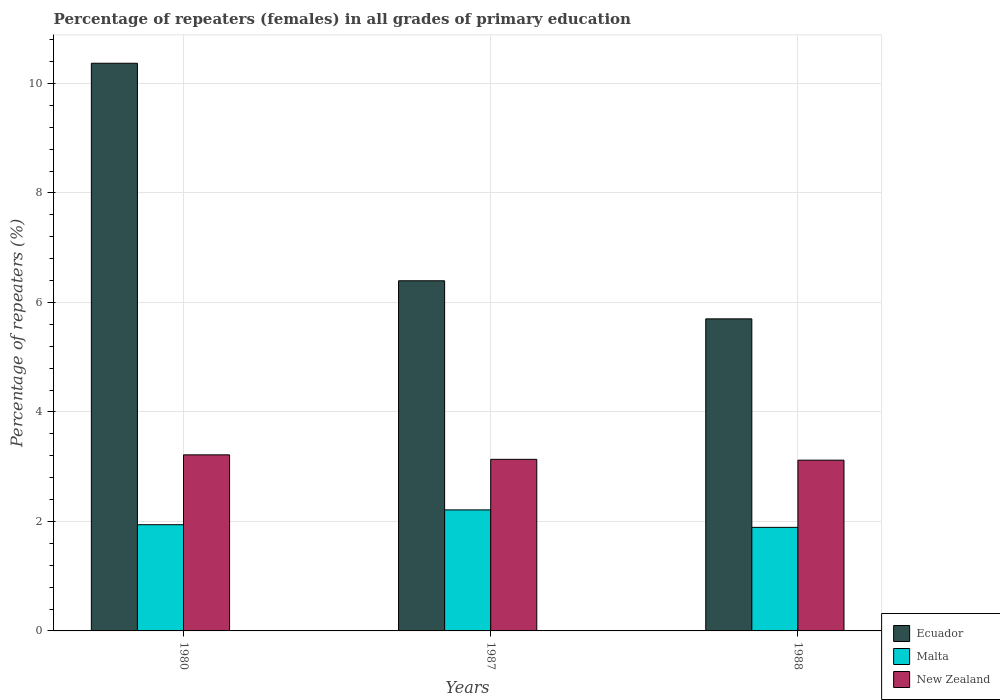How many different coloured bars are there?
Keep it short and to the point. 3. How many bars are there on the 3rd tick from the right?
Provide a short and direct response. 3. What is the label of the 1st group of bars from the left?
Your answer should be compact. 1980. In how many cases, is the number of bars for a given year not equal to the number of legend labels?
Give a very brief answer. 0. What is the percentage of repeaters (females) in Malta in 1988?
Your response must be concise. 1.89. Across all years, what is the maximum percentage of repeaters (females) in New Zealand?
Make the answer very short. 3.22. Across all years, what is the minimum percentage of repeaters (females) in Malta?
Your answer should be very brief. 1.89. In which year was the percentage of repeaters (females) in Ecuador minimum?
Make the answer very short. 1988. What is the total percentage of repeaters (females) in Ecuador in the graph?
Your answer should be compact. 22.46. What is the difference between the percentage of repeaters (females) in Ecuador in 1980 and that in 1988?
Provide a short and direct response. 4.67. What is the difference between the percentage of repeaters (females) in New Zealand in 1988 and the percentage of repeaters (females) in Malta in 1980?
Provide a short and direct response. 1.18. What is the average percentage of repeaters (females) in Malta per year?
Offer a very short reply. 2.01. In the year 1987, what is the difference between the percentage of repeaters (females) in New Zealand and percentage of repeaters (females) in Ecuador?
Your response must be concise. -3.26. In how many years, is the percentage of repeaters (females) in New Zealand greater than 2 %?
Give a very brief answer. 3. What is the ratio of the percentage of repeaters (females) in Ecuador in 1980 to that in 1988?
Ensure brevity in your answer.  1.82. What is the difference between the highest and the second highest percentage of repeaters (females) in Ecuador?
Your response must be concise. 3.97. What is the difference between the highest and the lowest percentage of repeaters (females) in New Zealand?
Provide a succinct answer. 0.1. Is the sum of the percentage of repeaters (females) in Ecuador in 1987 and 1988 greater than the maximum percentage of repeaters (females) in Malta across all years?
Provide a succinct answer. Yes. What does the 3rd bar from the left in 1980 represents?
Keep it short and to the point. New Zealand. What does the 1st bar from the right in 1980 represents?
Offer a terse response. New Zealand. Are all the bars in the graph horizontal?
Give a very brief answer. No. How many years are there in the graph?
Offer a very short reply. 3. What is the difference between two consecutive major ticks on the Y-axis?
Make the answer very short. 2. Are the values on the major ticks of Y-axis written in scientific E-notation?
Make the answer very short. No. Does the graph contain grids?
Make the answer very short. Yes. How many legend labels are there?
Your response must be concise. 3. How are the legend labels stacked?
Keep it short and to the point. Vertical. What is the title of the graph?
Your response must be concise. Percentage of repeaters (females) in all grades of primary education. Does "Lebanon" appear as one of the legend labels in the graph?
Provide a short and direct response. No. What is the label or title of the Y-axis?
Offer a terse response. Percentage of repeaters (%). What is the Percentage of repeaters (%) in Ecuador in 1980?
Your answer should be compact. 10.37. What is the Percentage of repeaters (%) of Malta in 1980?
Provide a succinct answer. 1.94. What is the Percentage of repeaters (%) of New Zealand in 1980?
Provide a short and direct response. 3.22. What is the Percentage of repeaters (%) in Ecuador in 1987?
Your answer should be very brief. 6.4. What is the Percentage of repeaters (%) of Malta in 1987?
Keep it short and to the point. 2.21. What is the Percentage of repeaters (%) in New Zealand in 1987?
Offer a very short reply. 3.13. What is the Percentage of repeaters (%) of Ecuador in 1988?
Your response must be concise. 5.7. What is the Percentage of repeaters (%) in Malta in 1988?
Ensure brevity in your answer.  1.89. What is the Percentage of repeaters (%) in New Zealand in 1988?
Your response must be concise. 3.12. Across all years, what is the maximum Percentage of repeaters (%) of Ecuador?
Keep it short and to the point. 10.37. Across all years, what is the maximum Percentage of repeaters (%) in Malta?
Give a very brief answer. 2.21. Across all years, what is the maximum Percentage of repeaters (%) in New Zealand?
Offer a very short reply. 3.22. Across all years, what is the minimum Percentage of repeaters (%) in Ecuador?
Give a very brief answer. 5.7. Across all years, what is the minimum Percentage of repeaters (%) of Malta?
Keep it short and to the point. 1.89. Across all years, what is the minimum Percentage of repeaters (%) in New Zealand?
Your answer should be very brief. 3.12. What is the total Percentage of repeaters (%) of Ecuador in the graph?
Provide a short and direct response. 22.46. What is the total Percentage of repeaters (%) of Malta in the graph?
Offer a terse response. 6.04. What is the total Percentage of repeaters (%) of New Zealand in the graph?
Provide a succinct answer. 9.47. What is the difference between the Percentage of repeaters (%) in Ecuador in 1980 and that in 1987?
Your answer should be compact. 3.97. What is the difference between the Percentage of repeaters (%) of Malta in 1980 and that in 1987?
Ensure brevity in your answer.  -0.27. What is the difference between the Percentage of repeaters (%) of New Zealand in 1980 and that in 1987?
Ensure brevity in your answer.  0.08. What is the difference between the Percentage of repeaters (%) in Ecuador in 1980 and that in 1988?
Make the answer very short. 4.67. What is the difference between the Percentage of repeaters (%) of Malta in 1980 and that in 1988?
Your answer should be compact. 0.05. What is the difference between the Percentage of repeaters (%) in New Zealand in 1980 and that in 1988?
Ensure brevity in your answer.  0.1. What is the difference between the Percentage of repeaters (%) of Ecuador in 1987 and that in 1988?
Your answer should be compact. 0.7. What is the difference between the Percentage of repeaters (%) in Malta in 1987 and that in 1988?
Ensure brevity in your answer.  0.32. What is the difference between the Percentage of repeaters (%) of New Zealand in 1987 and that in 1988?
Ensure brevity in your answer.  0.02. What is the difference between the Percentage of repeaters (%) of Ecuador in 1980 and the Percentage of repeaters (%) of Malta in 1987?
Offer a terse response. 8.16. What is the difference between the Percentage of repeaters (%) of Ecuador in 1980 and the Percentage of repeaters (%) of New Zealand in 1987?
Your answer should be very brief. 7.23. What is the difference between the Percentage of repeaters (%) of Malta in 1980 and the Percentage of repeaters (%) of New Zealand in 1987?
Provide a short and direct response. -1.19. What is the difference between the Percentage of repeaters (%) in Ecuador in 1980 and the Percentage of repeaters (%) in Malta in 1988?
Offer a very short reply. 8.48. What is the difference between the Percentage of repeaters (%) in Ecuador in 1980 and the Percentage of repeaters (%) in New Zealand in 1988?
Your response must be concise. 7.25. What is the difference between the Percentage of repeaters (%) of Malta in 1980 and the Percentage of repeaters (%) of New Zealand in 1988?
Provide a short and direct response. -1.18. What is the difference between the Percentage of repeaters (%) of Ecuador in 1987 and the Percentage of repeaters (%) of Malta in 1988?
Keep it short and to the point. 4.5. What is the difference between the Percentage of repeaters (%) in Ecuador in 1987 and the Percentage of repeaters (%) in New Zealand in 1988?
Make the answer very short. 3.28. What is the difference between the Percentage of repeaters (%) in Malta in 1987 and the Percentage of repeaters (%) in New Zealand in 1988?
Your response must be concise. -0.91. What is the average Percentage of repeaters (%) of Ecuador per year?
Your answer should be very brief. 7.49. What is the average Percentage of repeaters (%) in Malta per year?
Keep it short and to the point. 2.01. What is the average Percentage of repeaters (%) in New Zealand per year?
Offer a terse response. 3.16. In the year 1980, what is the difference between the Percentage of repeaters (%) of Ecuador and Percentage of repeaters (%) of Malta?
Ensure brevity in your answer.  8.43. In the year 1980, what is the difference between the Percentage of repeaters (%) in Ecuador and Percentage of repeaters (%) in New Zealand?
Your answer should be compact. 7.15. In the year 1980, what is the difference between the Percentage of repeaters (%) of Malta and Percentage of repeaters (%) of New Zealand?
Offer a very short reply. -1.28. In the year 1987, what is the difference between the Percentage of repeaters (%) in Ecuador and Percentage of repeaters (%) in Malta?
Provide a short and direct response. 4.18. In the year 1987, what is the difference between the Percentage of repeaters (%) of Ecuador and Percentage of repeaters (%) of New Zealand?
Provide a short and direct response. 3.26. In the year 1987, what is the difference between the Percentage of repeaters (%) in Malta and Percentage of repeaters (%) in New Zealand?
Keep it short and to the point. -0.92. In the year 1988, what is the difference between the Percentage of repeaters (%) of Ecuador and Percentage of repeaters (%) of Malta?
Ensure brevity in your answer.  3.81. In the year 1988, what is the difference between the Percentage of repeaters (%) in Ecuador and Percentage of repeaters (%) in New Zealand?
Your response must be concise. 2.58. In the year 1988, what is the difference between the Percentage of repeaters (%) of Malta and Percentage of repeaters (%) of New Zealand?
Your response must be concise. -1.23. What is the ratio of the Percentage of repeaters (%) in Ecuador in 1980 to that in 1987?
Offer a very short reply. 1.62. What is the ratio of the Percentage of repeaters (%) in Malta in 1980 to that in 1987?
Your answer should be very brief. 0.88. What is the ratio of the Percentage of repeaters (%) in New Zealand in 1980 to that in 1987?
Provide a short and direct response. 1.03. What is the ratio of the Percentage of repeaters (%) in Ecuador in 1980 to that in 1988?
Your response must be concise. 1.82. What is the ratio of the Percentage of repeaters (%) in Malta in 1980 to that in 1988?
Keep it short and to the point. 1.03. What is the ratio of the Percentage of repeaters (%) in New Zealand in 1980 to that in 1988?
Your answer should be compact. 1.03. What is the ratio of the Percentage of repeaters (%) of Ecuador in 1987 to that in 1988?
Your answer should be compact. 1.12. What is the ratio of the Percentage of repeaters (%) of Malta in 1987 to that in 1988?
Keep it short and to the point. 1.17. What is the ratio of the Percentage of repeaters (%) of New Zealand in 1987 to that in 1988?
Your answer should be compact. 1. What is the difference between the highest and the second highest Percentage of repeaters (%) of Ecuador?
Your answer should be compact. 3.97. What is the difference between the highest and the second highest Percentage of repeaters (%) in Malta?
Offer a terse response. 0.27. What is the difference between the highest and the second highest Percentage of repeaters (%) in New Zealand?
Offer a very short reply. 0.08. What is the difference between the highest and the lowest Percentage of repeaters (%) of Ecuador?
Provide a short and direct response. 4.67. What is the difference between the highest and the lowest Percentage of repeaters (%) of Malta?
Your response must be concise. 0.32. What is the difference between the highest and the lowest Percentage of repeaters (%) in New Zealand?
Keep it short and to the point. 0.1. 